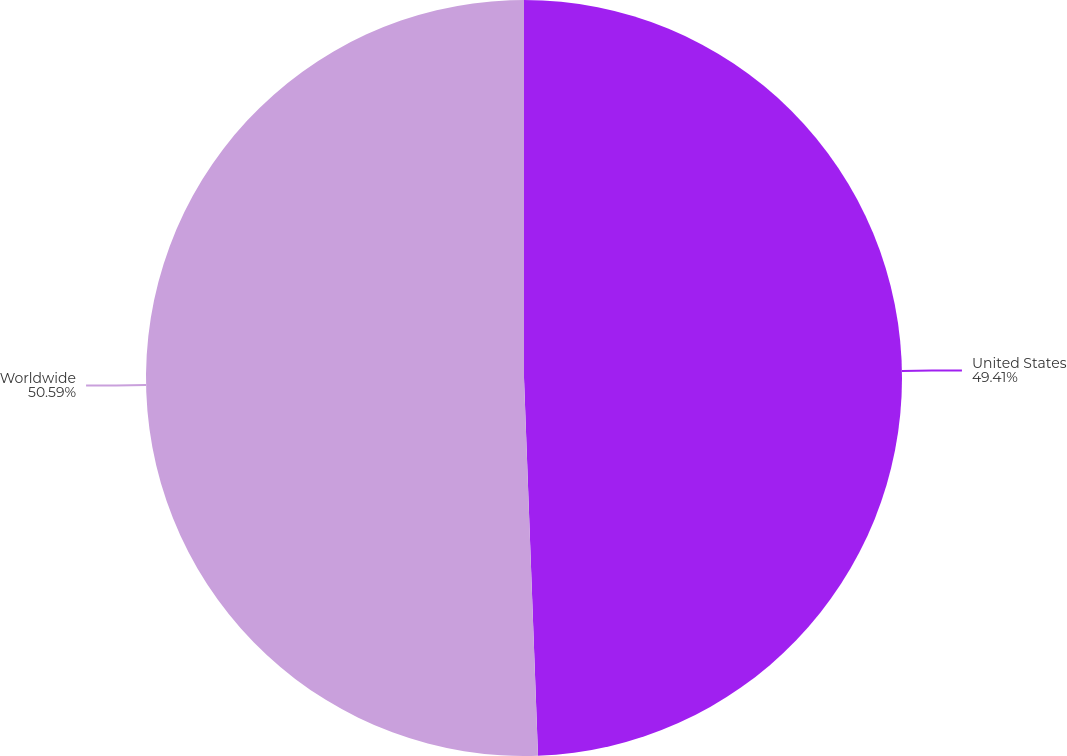Convert chart. <chart><loc_0><loc_0><loc_500><loc_500><pie_chart><fcel>United States<fcel>Worldwide<nl><fcel>49.41%<fcel>50.59%<nl></chart> 